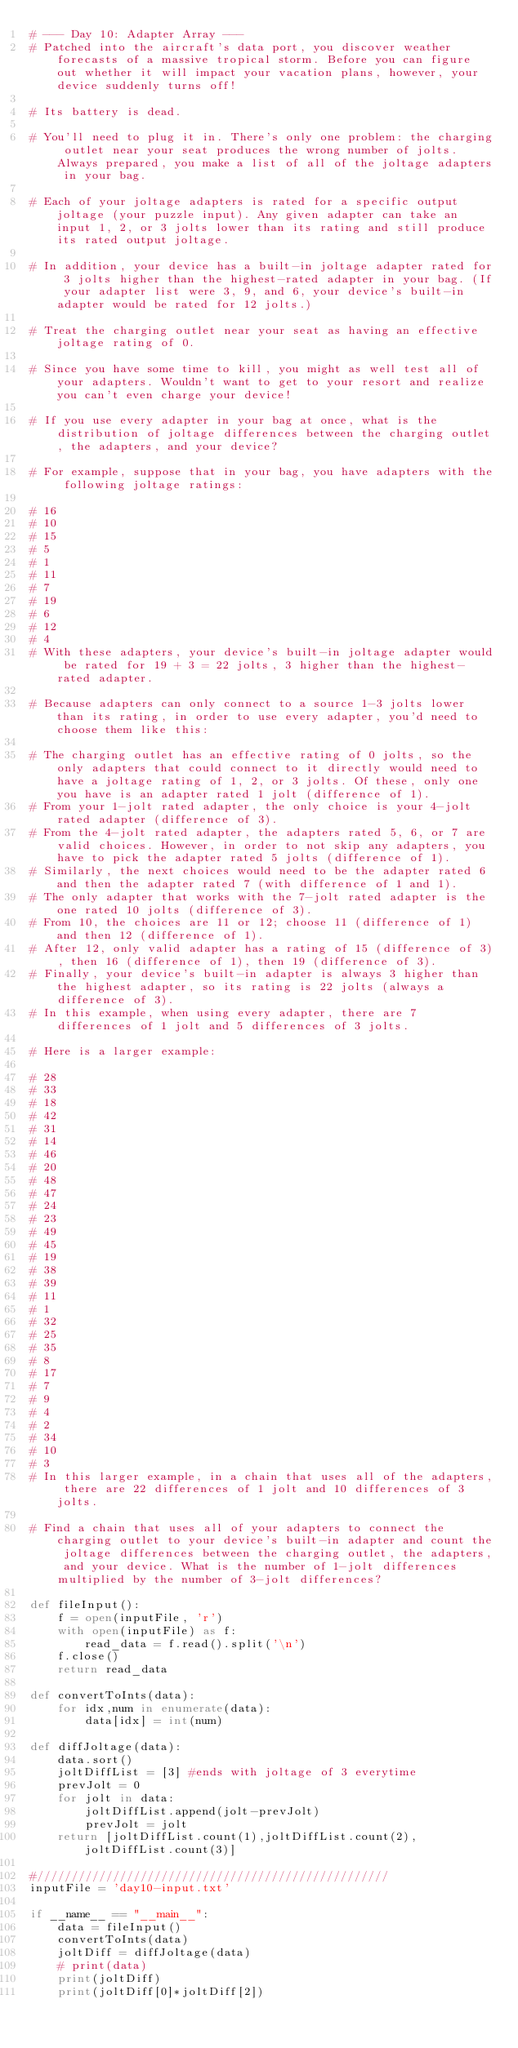<code> <loc_0><loc_0><loc_500><loc_500><_Python_># --- Day 10: Adapter Array ---
# Patched into the aircraft's data port, you discover weather forecasts of a massive tropical storm. Before you can figure out whether it will impact your vacation plans, however, your device suddenly turns off!

# Its battery is dead.

# You'll need to plug it in. There's only one problem: the charging outlet near your seat produces the wrong number of jolts. Always prepared, you make a list of all of the joltage adapters in your bag.

# Each of your joltage adapters is rated for a specific output joltage (your puzzle input). Any given adapter can take an input 1, 2, or 3 jolts lower than its rating and still produce its rated output joltage.

# In addition, your device has a built-in joltage adapter rated for 3 jolts higher than the highest-rated adapter in your bag. (If your adapter list were 3, 9, and 6, your device's built-in adapter would be rated for 12 jolts.)

# Treat the charging outlet near your seat as having an effective joltage rating of 0.

# Since you have some time to kill, you might as well test all of your adapters. Wouldn't want to get to your resort and realize you can't even charge your device!

# If you use every adapter in your bag at once, what is the distribution of joltage differences between the charging outlet, the adapters, and your device?

# For example, suppose that in your bag, you have adapters with the following joltage ratings:

# 16
# 10
# 15
# 5
# 1
# 11
# 7
# 19
# 6
# 12
# 4
# With these adapters, your device's built-in joltage adapter would be rated for 19 + 3 = 22 jolts, 3 higher than the highest-rated adapter.

# Because adapters can only connect to a source 1-3 jolts lower than its rating, in order to use every adapter, you'd need to choose them like this:

# The charging outlet has an effective rating of 0 jolts, so the only adapters that could connect to it directly would need to have a joltage rating of 1, 2, or 3 jolts. Of these, only one you have is an adapter rated 1 jolt (difference of 1).
# From your 1-jolt rated adapter, the only choice is your 4-jolt rated adapter (difference of 3).
# From the 4-jolt rated adapter, the adapters rated 5, 6, or 7 are valid choices. However, in order to not skip any adapters, you have to pick the adapter rated 5 jolts (difference of 1).
# Similarly, the next choices would need to be the adapter rated 6 and then the adapter rated 7 (with difference of 1 and 1).
# The only adapter that works with the 7-jolt rated adapter is the one rated 10 jolts (difference of 3).
# From 10, the choices are 11 or 12; choose 11 (difference of 1) and then 12 (difference of 1).
# After 12, only valid adapter has a rating of 15 (difference of 3), then 16 (difference of 1), then 19 (difference of 3).
# Finally, your device's built-in adapter is always 3 higher than the highest adapter, so its rating is 22 jolts (always a difference of 3).
# In this example, when using every adapter, there are 7 differences of 1 jolt and 5 differences of 3 jolts.

# Here is a larger example:

# 28
# 33
# 18
# 42
# 31
# 14
# 46
# 20
# 48
# 47
# 24
# 23
# 49
# 45
# 19
# 38
# 39
# 11
# 1
# 32
# 25
# 35
# 8
# 17
# 7
# 9
# 4
# 2
# 34
# 10
# 3
# In this larger example, in a chain that uses all of the adapters, there are 22 differences of 1 jolt and 10 differences of 3 jolts.

# Find a chain that uses all of your adapters to connect the charging outlet to your device's built-in adapter and count the joltage differences between the charging outlet, the adapters, and your device. What is the number of 1-jolt differences multiplied by the number of 3-jolt differences?

def fileInput():
    f = open(inputFile, 'r')
    with open(inputFile) as f:
        read_data = f.read().split('\n')
    f.close()
    return read_data

def convertToInts(data):
    for idx,num in enumerate(data):
        data[idx] = int(num)

def diffJoltage(data):
    data.sort()
    joltDiffList = [3] #ends with joltage of 3 everytime
    prevJolt = 0
    for jolt in data:
        joltDiffList.append(jolt-prevJolt)
        prevJolt = jolt
    return [joltDiffList.count(1),joltDiffList.count(2),joltDiffList.count(3)]

#///////////////////////////////////////////////////
inputFile = 'day10-input.txt'

if __name__ == "__main__":
    data = fileInput()
    convertToInts(data)
    joltDiff = diffJoltage(data)
    # print(data)
    print(joltDiff)
    print(joltDiff[0]*joltDiff[2])
    </code> 